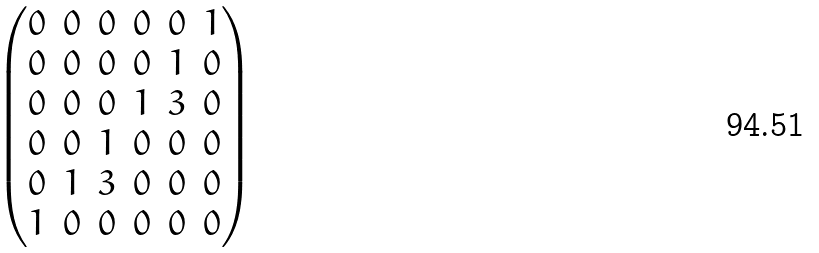Convert formula to latex. <formula><loc_0><loc_0><loc_500><loc_500>\begin{pmatrix} 0 & 0 & 0 & 0 & 0 & 1 \\ 0 & 0 & 0 & 0 & 1 & 0 \\ 0 & 0 & 0 & 1 & 3 & 0 \\ 0 & 0 & 1 & 0 & 0 & 0 \\ 0 & 1 & 3 & 0 & 0 & 0 \\ 1 & 0 & 0 & 0 & 0 & 0 \end{pmatrix}</formula> 